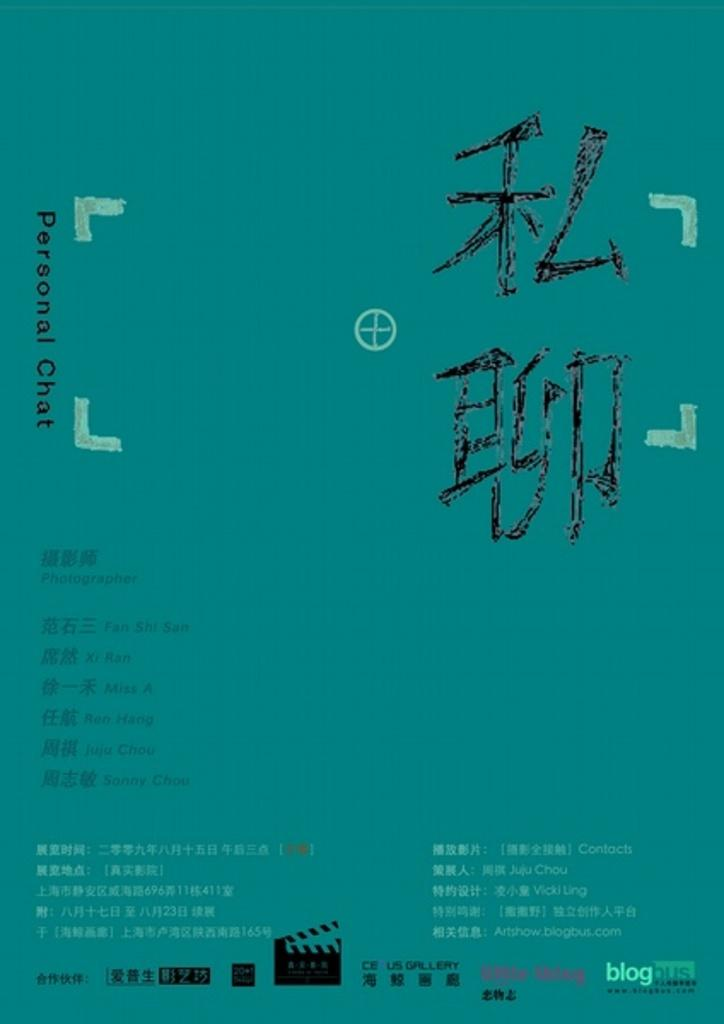<image>
Render a clear and concise summary of the photo. a blue poster that says blog in the bottom right 